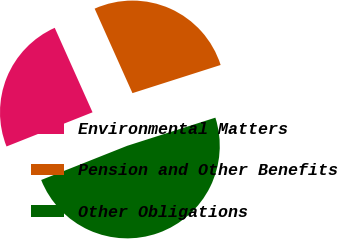Convert chart. <chart><loc_0><loc_0><loc_500><loc_500><pie_chart><fcel>Environmental Matters<fcel>Pension and Other Benefits<fcel>Other Obligations<nl><fcel>24.32%<fcel>26.78%<fcel>48.9%<nl></chart> 